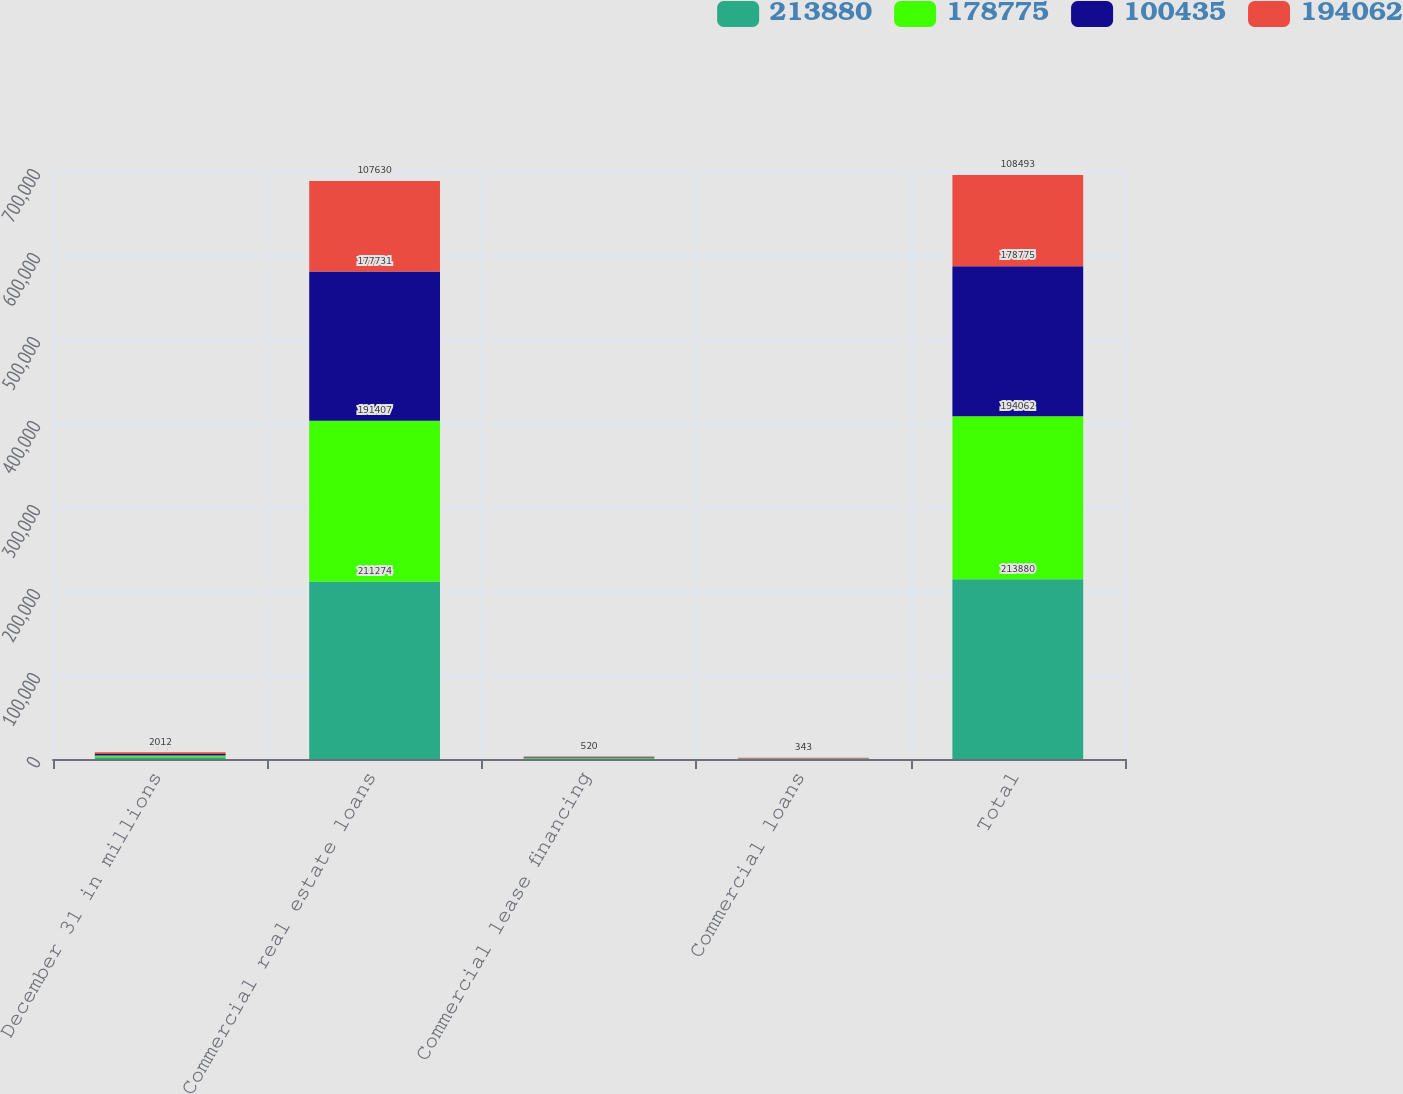Convert chart. <chart><loc_0><loc_0><loc_500><loc_500><stacked_bar_chart><ecel><fcel>December 31 in millions<fcel>Commercial real estate loans<fcel>Commercial lease financing<fcel>Commercial loans<fcel>Total<nl><fcel>213880<fcel>2015<fcel>211274<fcel>932<fcel>335<fcel>213880<nl><fcel>178775<fcel>2014<fcel>191407<fcel>722<fcel>344<fcel>194062<nl><fcel>100435<fcel>2013<fcel>177731<fcel>717<fcel>327<fcel>178775<nl><fcel>194062<fcel>2012<fcel>107630<fcel>520<fcel>343<fcel>108493<nl></chart> 